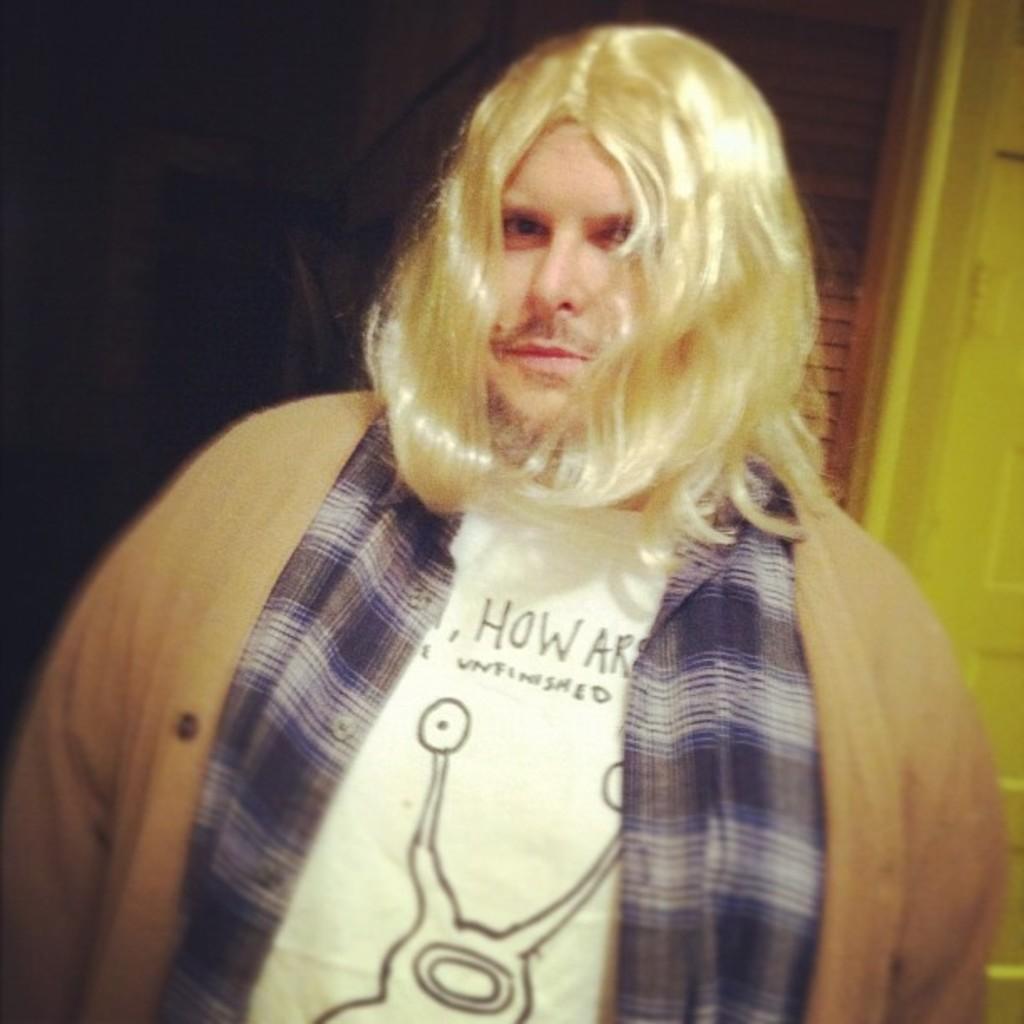How would you summarize this image in a sentence or two? In this image we can see a man. In the background the image is dark on the left side, an object, wooden object and a door. 